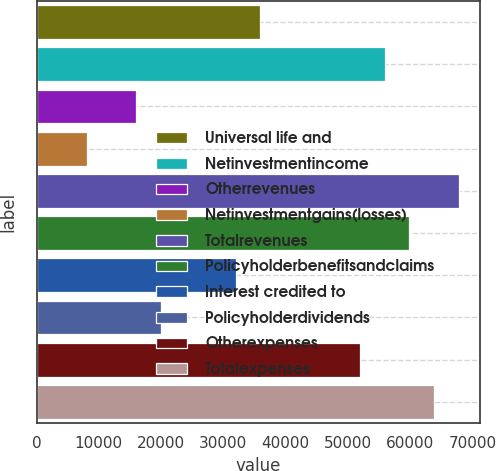Convert chart to OTSL. <chart><loc_0><loc_0><loc_500><loc_500><bar_chart><fcel>Universal life and<fcel>Netinvestmentincome<fcel>Otherrevenues<fcel>Netinvestmentgains(losses)<fcel>Totalrevenues<fcel>Policyholderbenefitsandclaims<fcel>Interest credited to<fcel>Policyholderdividends<fcel>Otherexpenses<fcel>Totalexpenses<nl><fcel>35935.2<fcel>55864.2<fcel>16006.2<fcel>8034.6<fcel>67821.6<fcel>59850<fcel>31949.4<fcel>19992<fcel>51878.4<fcel>63835.8<nl></chart> 